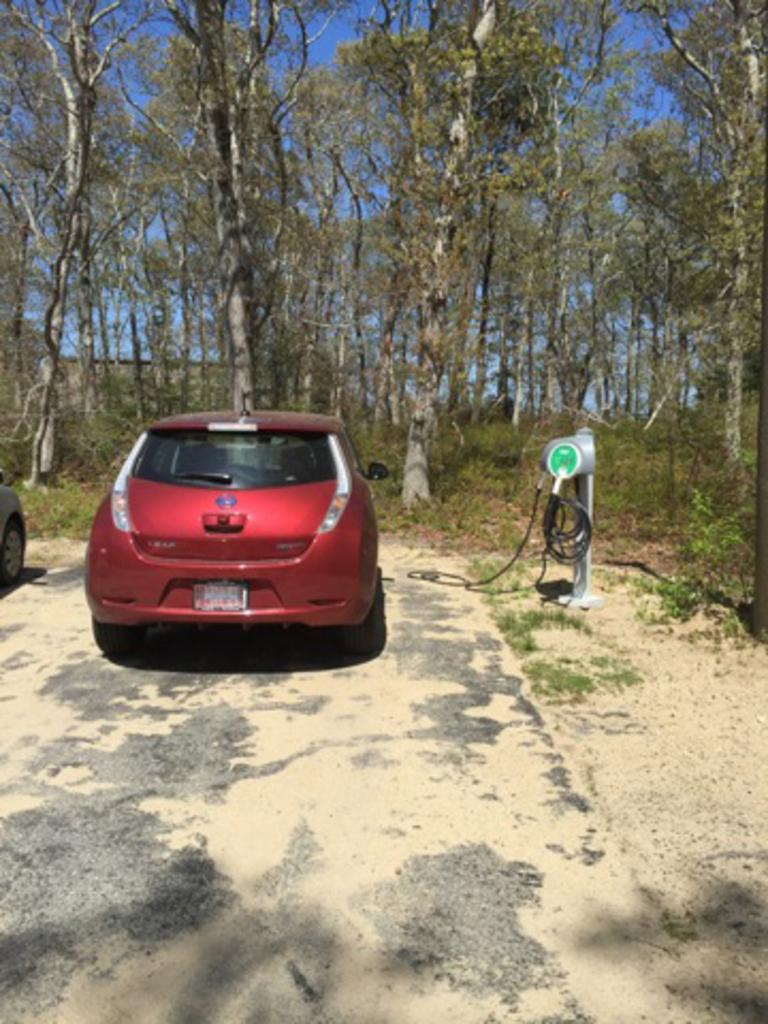What color is the car in the image? The car in the image is red. What type of vegetation can be seen in the image? There are trees visible in the image. Are there any other cars in the image? Yes, there is another car on the side of the red car. What is the ground covered with in the image? Grass is present on the ground. What color is the sky in the image? The sky is blue in the image. Is there a dock visible in the image? No, there is no dock present in the image. What type of comfort can be found in the car? The image does not provide information about the comfort level inside the car. 